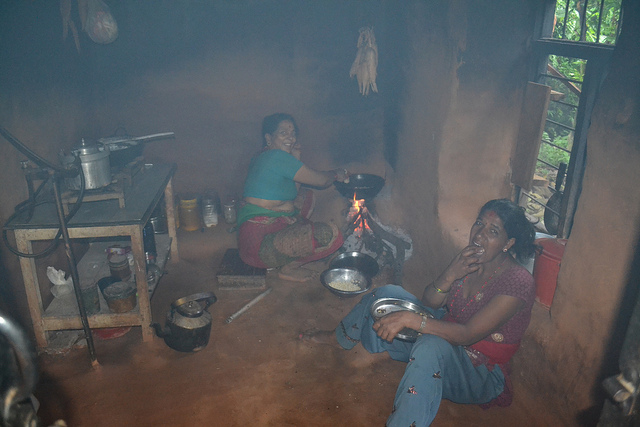<image>What is sitting on the shoes? There are no shoes in the image. What is sitting on the shoes? I don't know what is sitting on the shoes. It can be either nothing or dirt. 